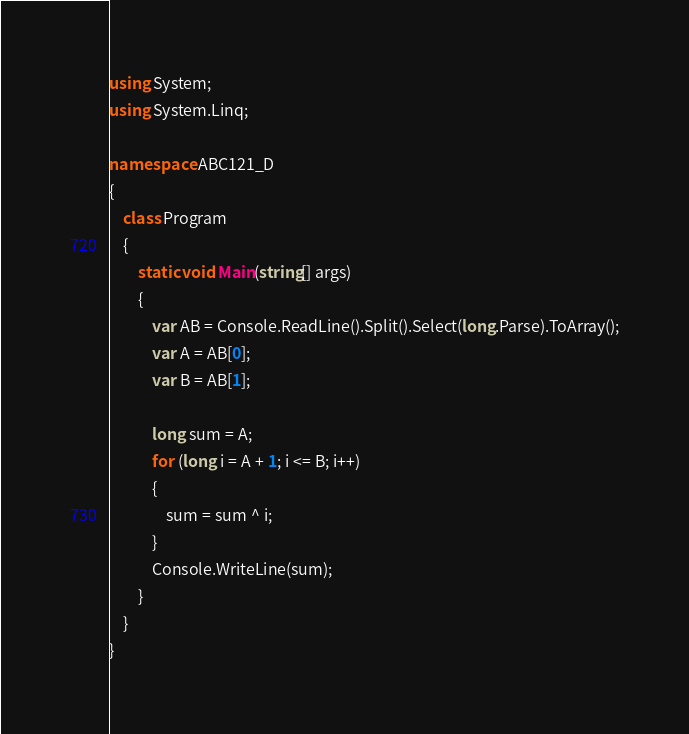<code> <loc_0><loc_0><loc_500><loc_500><_C#_>using System;
using System.Linq;

namespace ABC121_D
{
    class Program
    {
        static void Main(string[] args)
        {
            var AB = Console.ReadLine().Split().Select(long.Parse).ToArray();
            var A = AB[0];
            var B = AB[1];

            long sum = A;
            for (long i = A + 1; i <= B; i++)
            {
                sum = sum ^ i;
            }
            Console.WriteLine(sum);
        }
    }
}
</code> 